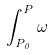Convert formula to latex. <formula><loc_0><loc_0><loc_500><loc_500>\int _ { P _ { 0 } } ^ { P } \omega</formula> 